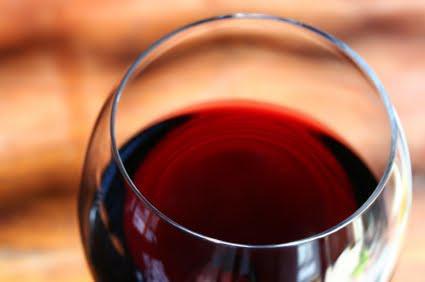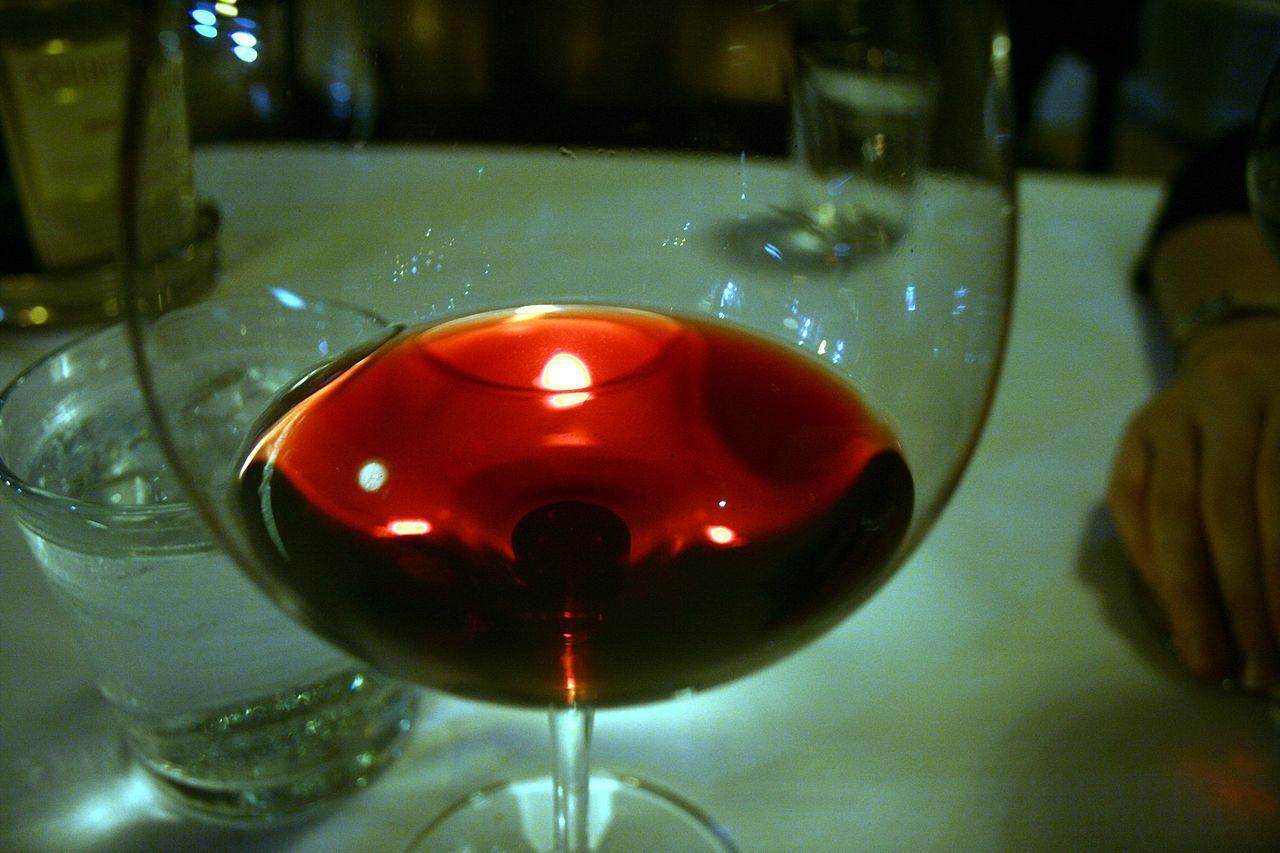The first image is the image on the left, the second image is the image on the right. For the images shown, is this caption "The entire wine glass can be seen in one of the images." true? Answer yes or no. No. 